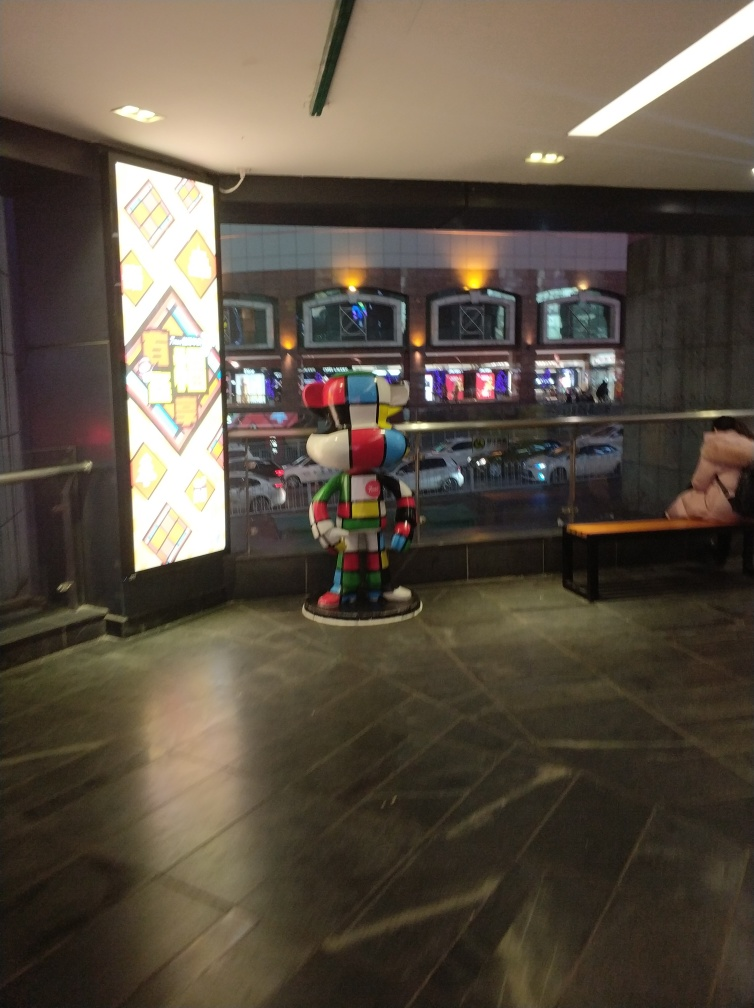Are there any quality issues with this image? Yes, the image exhibits several quality issues. It is blurred, likely due to camera shake or motion blur, which reduces the sharpness and detail. There is also evident noise, which could be due to low lighting conditions or a high ISO setting used during the capture. Furthermore, the composition is slightly skewed with a tilt to the right, and the exposure could be better balanced to enhance the visibility of the darker areas. 